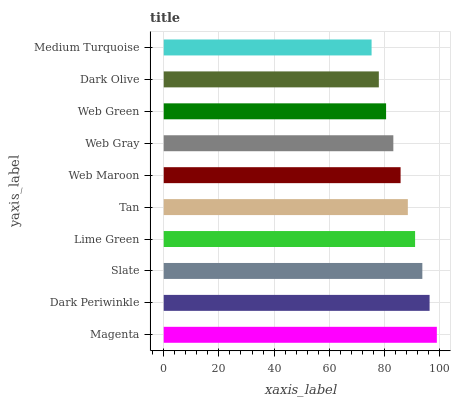Is Medium Turquoise the minimum?
Answer yes or no. Yes. Is Magenta the maximum?
Answer yes or no. Yes. Is Dark Periwinkle the minimum?
Answer yes or no. No. Is Dark Periwinkle the maximum?
Answer yes or no. No. Is Magenta greater than Dark Periwinkle?
Answer yes or no. Yes. Is Dark Periwinkle less than Magenta?
Answer yes or no. Yes. Is Dark Periwinkle greater than Magenta?
Answer yes or no. No. Is Magenta less than Dark Periwinkle?
Answer yes or no. No. Is Tan the high median?
Answer yes or no. Yes. Is Web Maroon the low median?
Answer yes or no. Yes. Is Lime Green the high median?
Answer yes or no. No. Is Medium Turquoise the low median?
Answer yes or no. No. 